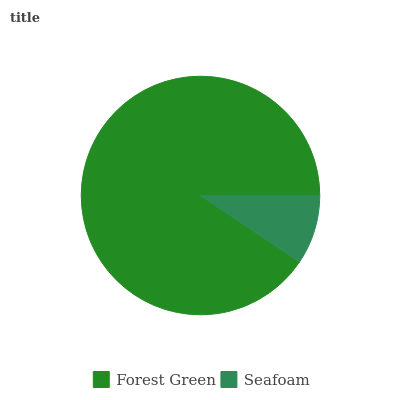Is Seafoam the minimum?
Answer yes or no. Yes. Is Forest Green the maximum?
Answer yes or no. Yes. Is Seafoam the maximum?
Answer yes or no. No. Is Forest Green greater than Seafoam?
Answer yes or no. Yes. Is Seafoam less than Forest Green?
Answer yes or no. Yes. Is Seafoam greater than Forest Green?
Answer yes or no. No. Is Forest Green less than Seafoam?
Answer yes or no. No. Is Forest Green the high median?
Answer yes or no. Yes. Is Seafoam the low median?
Answer yes or no. Yes. Is Seafoam the high median?
Answer yes or no. No. Is Forest Green the low median?
Answer yes or no. No. 